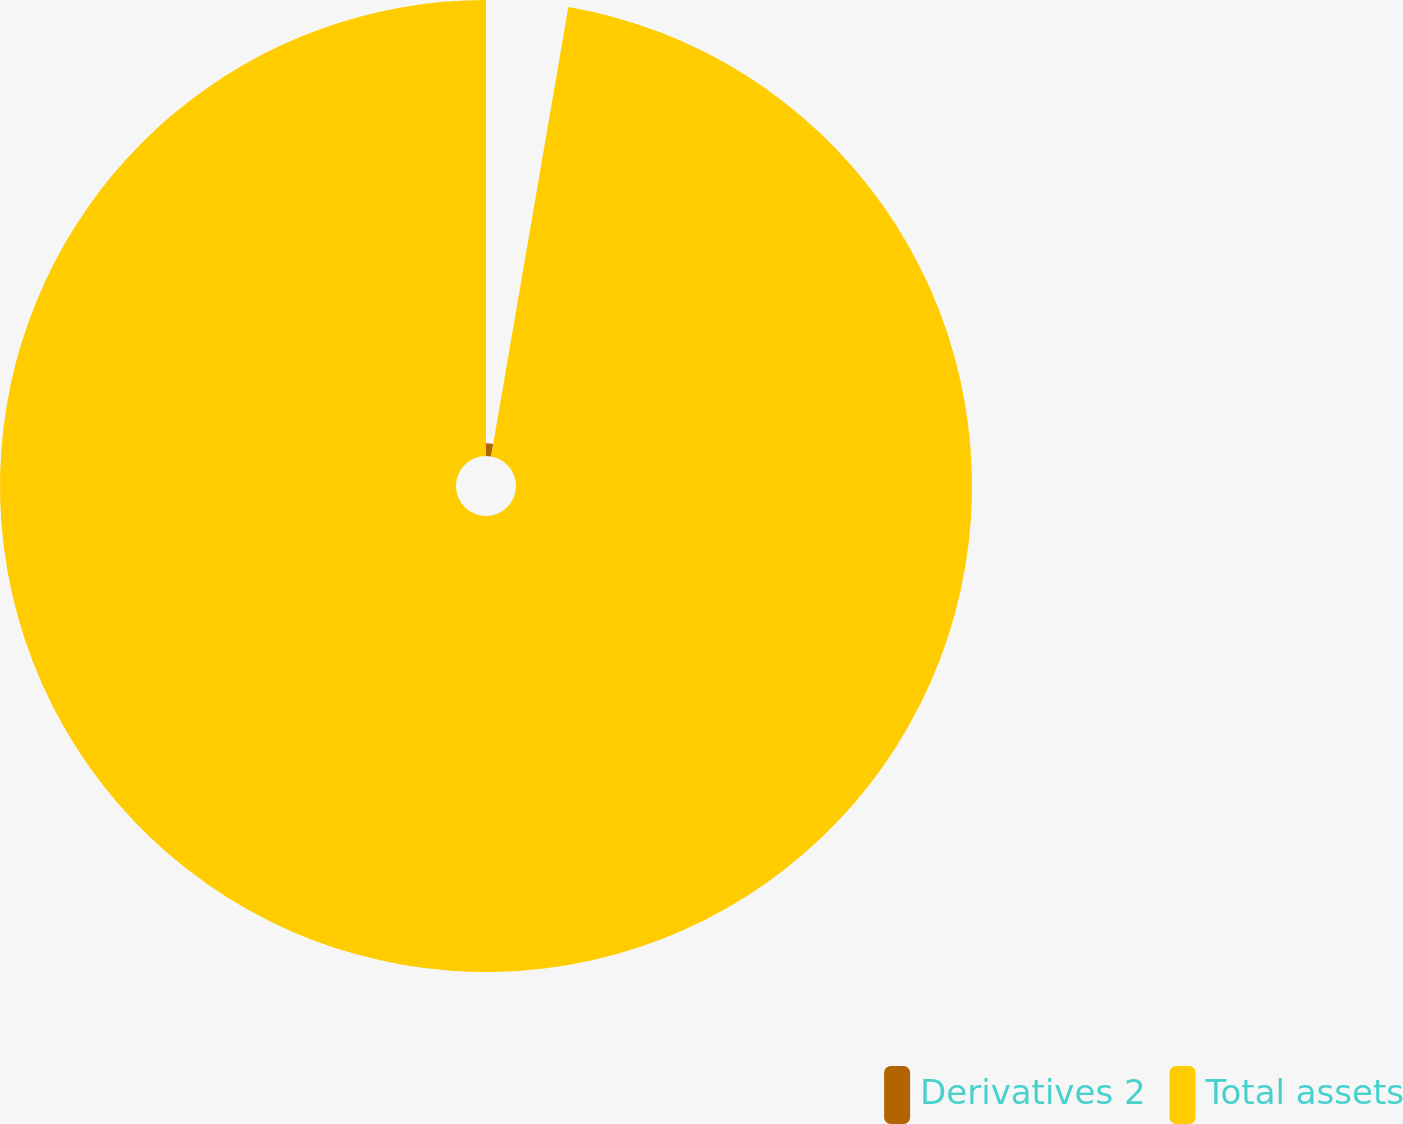Convert chart. <chart><loc_0><loc_0><loc_500><loc_500><pie_chart><fcel>Derivatives 2<fcel>Total assets<nl><fcel>2.71%<fcel>97.29%<nl></chart> 